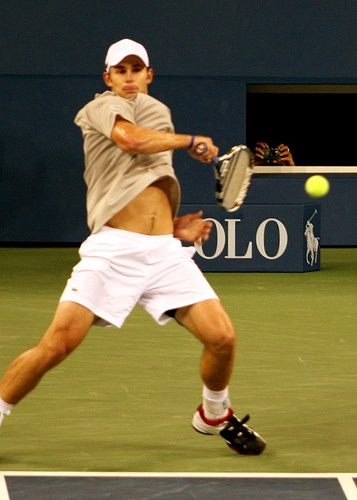Describe the objects in this image and their specific colors. I can see people in black, white, orange, and brown tones, tennis racket in black, tan, and olive tones, people in black, maroon, and brown tones, and sports ball in black, yellow, and olive tones in this image. 